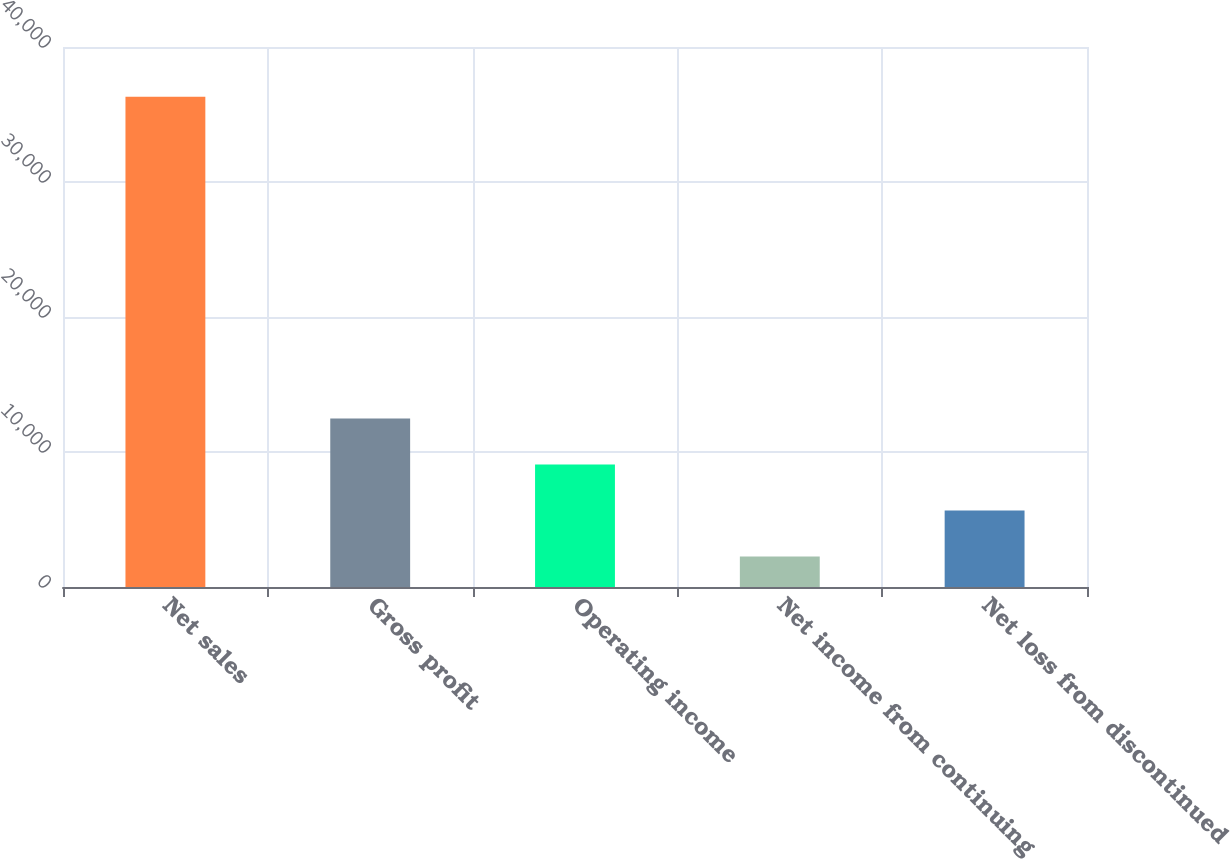Convert chart. <chart><loc_0><loc_0><loc_500><loc_500><bar_chart><fcel>Net sales<fcel>Gross profit<fcel>Operating income<fcel>Net income from continuing<fcel>Net loss from discontinued<nl><fcel>36324<fcel>12480.6<fcel>9074.4<fcel>2262<fcel>5668.2<nl></chart> 